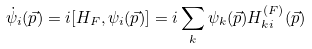Convert formula to latex. <formula><loc_0><loc_0><loc_500><loc_500>\dot { \psi } _ { i } ( \vec { p } ) = i [ H _ { F } , \psi _ { i } ( \vec { p } ) ] = i \sum _ { k } \psi _ { k } ( \vec { p } ) H _ { k i } ^ { ( F ) } ( \vec { p } )</formula> 